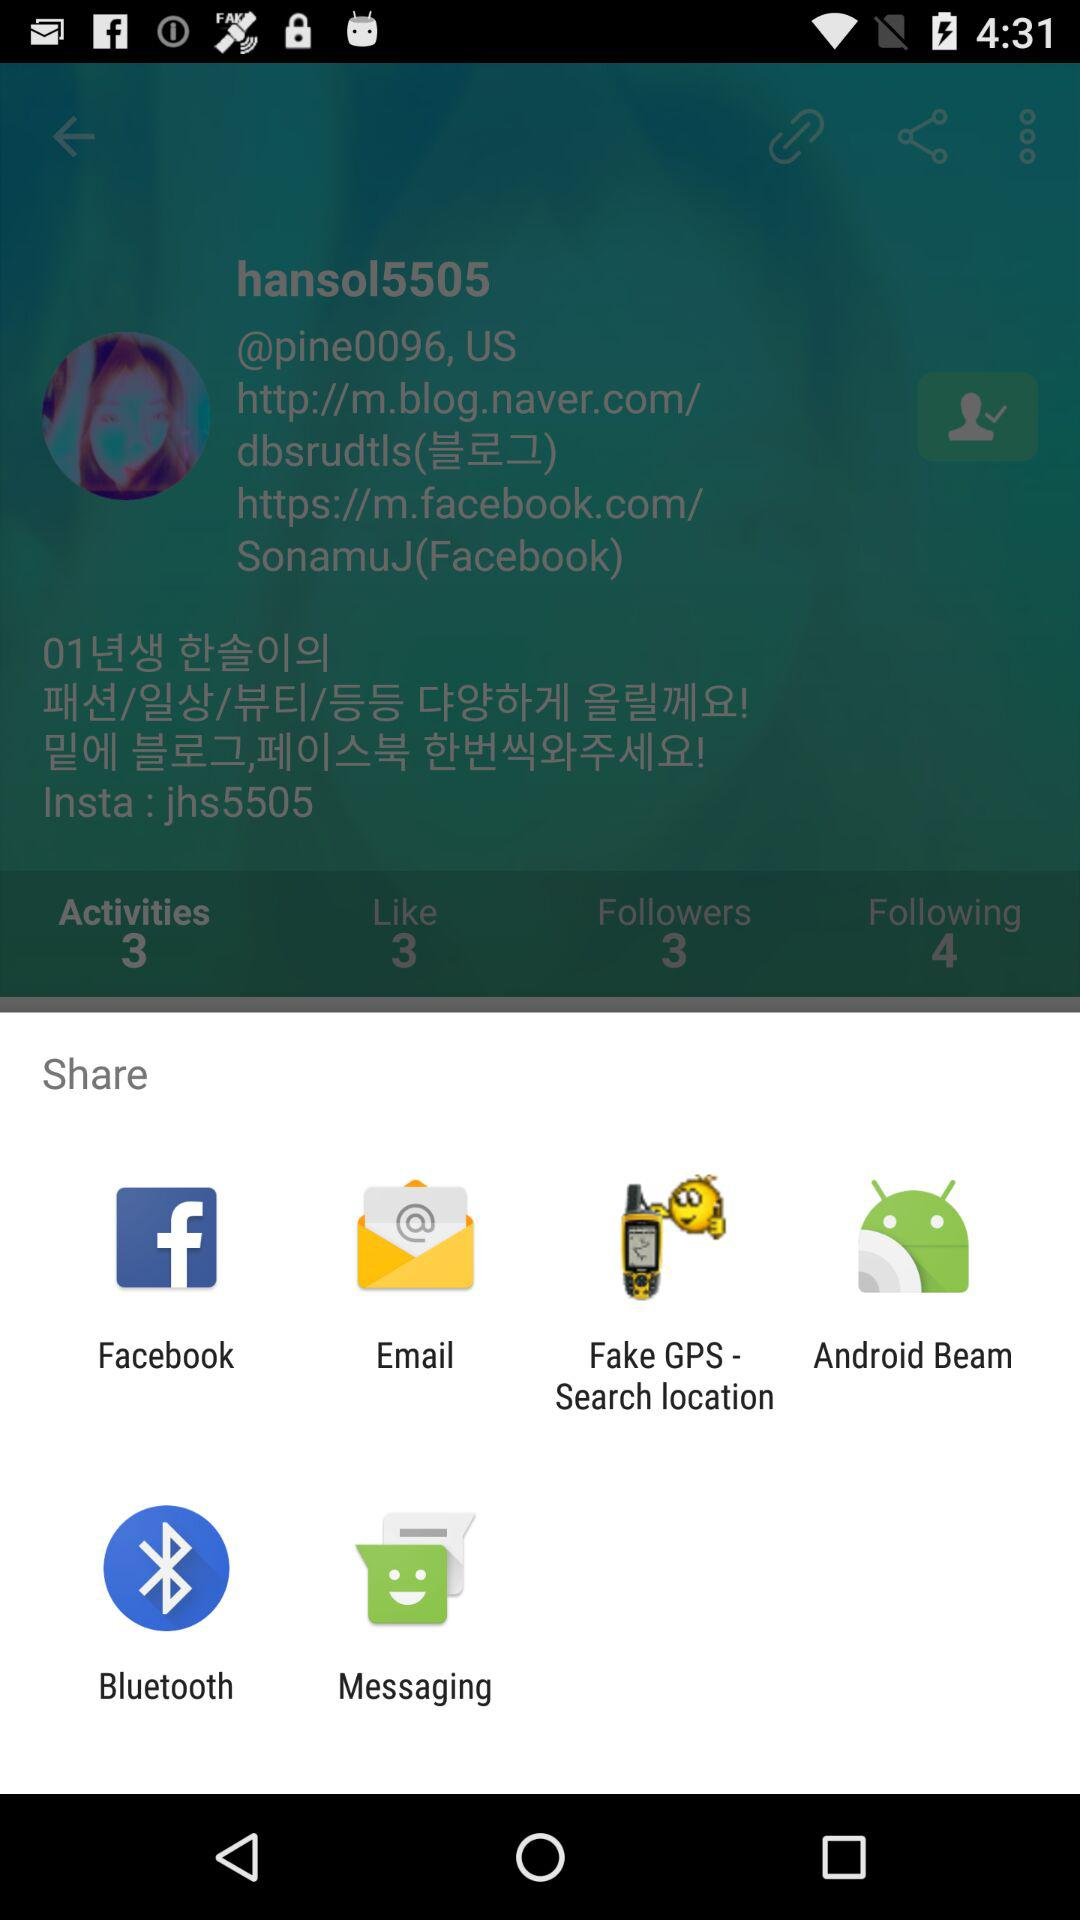Through what application can be shared? You can share it with Facebook, Email, Fake GPS - Search location, Android Beam, Bluetooth and Messaging. 